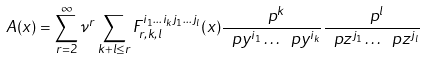<formula> <loc_0><loc_0><loc_500><loc_500>A ( x ) = \sum _ { r = 2 } ^ { \infty } \nu ^ { r } \sum _ { k + l \leq r } F _ { r , k , l } ^ { i _ { 1 } \dots i _ { k } j _ { 1 } \dots j _ { l } } ( x ) \frac { \ p ^ { k } } { \ p y ^ { i _ { 1 } } \dots \ p y ^ { i _ { k } } } \frac { \ p ^ { l } } { \ p z ^ { j _ { 1 } } \dots \ p z ^ { j _ { l } } }</formula> 